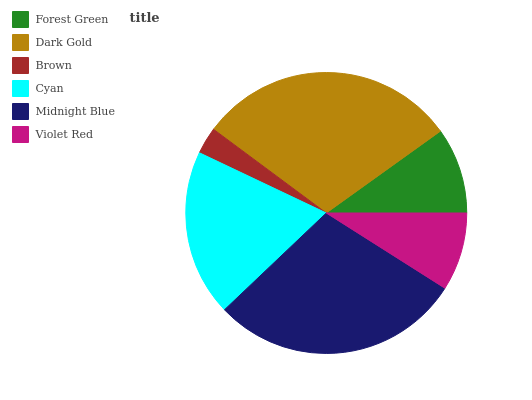Is Brown the minimum?
Answer yes or no. Yes. Is Dark Gold the maximum?
Answer yes or no. Yes. Is Dark Gold the minimum?
Answer yes or no. No. Is Brown the maximum?
Answer yes or no. No. Is Dark Gold greater than Brown?
Answer yes or no. Yes. Is Brown less than Dark Gold?
Answer yes or no. Yes. Is Brown greater than Dark Gold?
Answer yes or no. No. Is Dark Gold less than Brown?
Answer yes or no. No. Is Cyan the high median?
Answer yes or no. Yes. Is Forest Green the low median?
Answer yes or no. Yes. Is Forest Green the high median?
Answer yes or no. No. Is Cyan the low median?
Answer yes or no. No. 